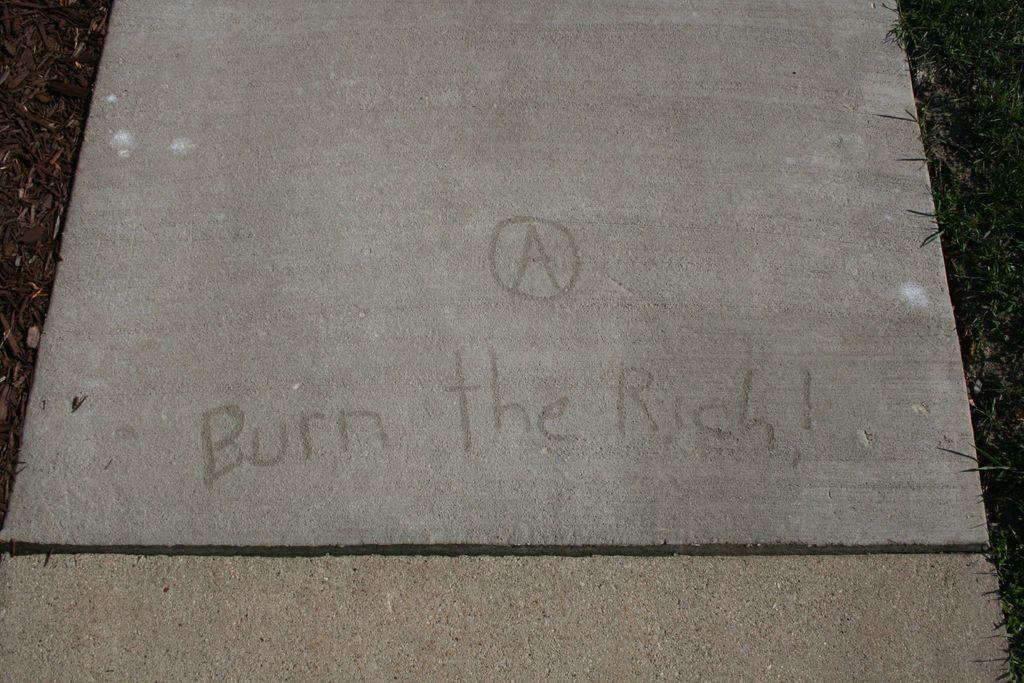Could you give a brief overview of what you see in this image? In the image we can see there is a stone tile kept on the ground and its written ¨Burn the Rich¨ on it. The ground is covered with grass. 